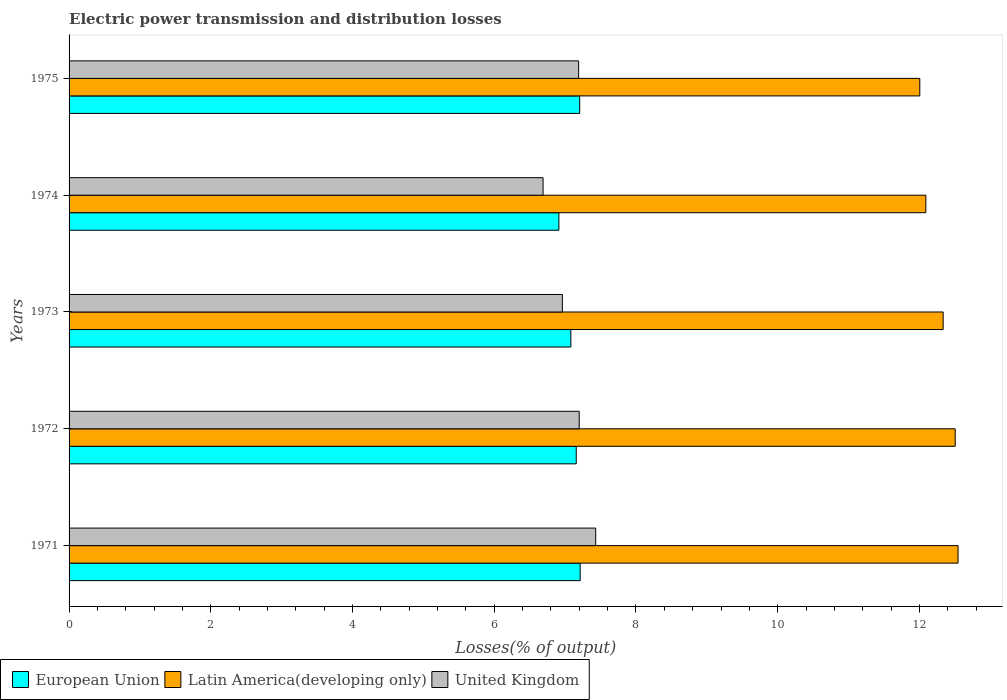Are the number of bars per tick equal to the number of legend labels?
Offer a terse response. Yes. Are the number of bars on each tick of the Y-axis equal?
Offer a terse response. Yes. How many bars are there on the 3rd tick from the top?
Offer a very short reply. 3. How many bars are there on the 4th tick from the bottom?
Provide a short and direct response. 3. What is the electric power transmission and distribution losses in United Kingdom in 1974?
Make the answer very short. 6.69. Across all years, what is the maximum electric power transmission and distribution losses in United Kingdom?
Offer a terse response. 7.43. Across all years, what is the minimum electric power transmission and distribution losses in United Kingdom?
Your response must be concise. 6.69. In which year was the electric power transmission and distribution losses in European Union maximum?
Ensure brevity in your answer.  1971. In which year was the electric power transmission and distribution losses in European Union minimum?
Your response must be concise. 1974. What is the total electric power transmission and distribution losses in Latin America(developing only) in the graph?
Your answer should be very brief. 61.48. What is the difference between the electric power transmission and distribution losses in United Kingdom in 1971 and that in 1973?
Ensure brevity in your answer.  0.47. What is the difference between the electric power transmission and distribution losses in European Union in 1975 and the electric power transmission and distribution losses in Latin America(developing only) in 1972?
Make the answer very short. -5.3. What is the average electric power transmission and distribution losses in Latin America(developing only) per year?
Ensure brevity in your answer.  12.3. In the year 1974, what is the difference between the electric power transmission and distribution losses in Latin America(developing only) and electric power transmission and distribution losses in European Union?
Ensure brevity in your answer.  5.18. What is the ratio of the electric power transmission and distribution losses in United Kingdom in 1974 to that in 1975?
Ensure brevity in your answer.  0.93. Is the difference between the electric power transmission and distribution losses in Latin America(developing only) in 1971 and 1975 greater than the difference between the electric power transmission and distribution losses in European Union in 1971 and 1975?
Provide a succinct answer. Yes. What is the difference between the highest and the second highest electric power transmission and distribution losses in United Kingdom?
Your response must be concise. 0.23. What is the difference between the highest and the lowest electric power transmission and distribution losses in European Union?
Offer a very short reply. 0.3. Is the sum of the electric power transmission and distribution losses in Latin America(developing only) in 1971 and 1975 greater than the maximum electric power transmission and distribution losses in European Union across all years?
Your response must be concise. Yes. What does the 2nd bar from the top in 1975 represents?
Make the answer very short. Latin America(developing only). What does the 2nd bar from the bottom in 1974 represents?
Ensure brevity in your answer.  Latin America(developing only). How many bars are there?
Make the answer very short. 15. Are all the bars in the graph horizontal?
Keep it short and to the point. Yes. How many years are there in the graph?
Your response must be concise. 5. What is the difference between two consecutive major ticks on the X-axis?
Your answer should be compact. 2. Does the graph contain any zero values?
Offer a very short reply. No. How are the legend labels stacked?
Your answer should be very brief. Horizontal. What is the title of the graph?
Provide a short and direct response. Electric power transmission and distribution losses. Does "Tunisia" appear as one of the legend labels in the graph?
Offer a very short reply. No. What is the label or title of the X-axis?
Offer a terse response. Losses(% of output). What is the Losses(% of output) of European Union in 1971?
Provide a succinct answer. 7.21. What is the Losses(% of output) of Latin America(developing only) in 1971?
Make the answer very short. 12.55. What is the Losses(% of output) of United Kingdom in 1971?
Your answer should be compact. 7.43. What is the Losses(% of output) in European Union in 1972?
Provide a short and direct response. 7.16. What is the Losses(% of output) of Latin America(developing only) in 1972?
Make the answer very short. 12.51. What is the Losses(% of output) in United Kingdom in 1972?
Your response must be concise. 7.2. What is the Losses(% of output) in European Union in 1973?
Your answer should be compact. 7.08. What is the Losses(% of output) of Latin America(developing only) in 1973?
Provide a short and direct response. 12.33. What is the Losses(% of output) in United Kingdom in 1973?
Your answer should be very brief. 6.96. What is the Losses(% of output) in European Union in 1974?
Your response must be concise. 6.91. What is the Losses(% of output) in Latin America(developing only) in 1974?
Offer a terse response. 12.09. What is the Losses(% of output) in United Kingdom in 1974?
Provide a succinct answer. 6.69. What is the Losses(% of output) in European Union in 1975?
Offer a terse response. 7.21. What is the Losses(% of output) of Latin America(developing only) in 1975?
Keep it short and to the point. 12.01. What is the Losses(% of output) in United Kingdom in 1975?
Your response must be concise. 7.19. Across all years, what is the maximum Losses(% of output) of European Union?
Provide a short and direct response. 7.21. Across all years, what is the maximum Losses(% of output) in Latin America(developing only)?
Make the answer very short. 12.55. Across all years, what is the maximum Losses(% of output) of United Kingdom?
Provide a short and direct response. 7.43. Across all years, what is the minimum Losses(% of output) of European Union?
Keep it short and to the point. 6.91. Across all years, what is the minimum Losses(% of output) in Latin America(developing only)?
Give a very brief answer. 12.01. Across all years, what is the minimum Losses(% of output) of United Kingdom?
Your answer should be compact. 6.69. What is the total Losses(% of output) of European Union in the graph?
Your response must be concise. 35.57. What is the total Losses(% of output) in Latin America(developing only) in the graph?
Your response must be concise. 61.48. What is the total Losses(% of output) of United Kingdom in the graph?
Your answer should be very brief. 35.47. What is the difference between the Losses(% of output) in European Union in 1971 and that in 1972?
Your response must be concise. 0.06. What is the difference between the Losses(% of output) in Latin America(developing only) in 1971 and that in 1972?
Your answer should be compact. 0.04. What is the difference between the Losses(% of output) of United Kingdom in 1971 and that in 1972?
Offer a very short reply. 0.23. What is the difference between the Losses(% of output) in European Union in 1971 and that in 1973?
Your answer should be compact. 0.13. What is the difference between the Losses(% of output) in Latin America(developing only) in 1971 and that in 1973?
Your answer should be very brief. 0.21. What is the difference between the Losses(% of output) of United Kingdom in 1971 and that in 1973?
Ensure brevity in your answer.  0.47. What is the difference between the Losses(% of output) of European Union in 1971 and that in 1974?
Make the answer very short. 0.3. What is the difference between the Losses(% of output) in Latin America(developing only) in 1971 and that in 1974?
Offer a very short reply. 0.45. What is the difference between the Losses(% of output) in United Kingdom in 1971 and that in 1974?
Your answer should be very brief. 0.74. What is the difference between the Losses(% of output) in European Union in 1971 and that in 1975?
Offer a terse response. 0.01. What is the difference between the Losses(% of output) in Latin America(developing only) in 1971 and that in 1975?
Provide a short and direct response. 0.54. What is the difference between the Losses(% of output) in United Kingdom in 1971 and that in 1975?
Your answer should be compact. 0.24. What is the difference between the Losses(% of output) of European Union in 1972 and that in 1973?
Give a very brief answer. 0.08. What is the difference between the Losses(% of output) in Latin America(developing only) in 1972 and that in 1973?
Your answer should be very brief. 0.17. What is the difference between the Losses(% of output) in United Kingdom in 1972 and that in 1973?
Give a very brief answer. 0.24. What is the difference between the Losses(% of output) of European Union in 1972 and that in 1974?
Ensure brevity in your answer.  0.24. What is the difference between the Losses(% of output) in Latin America(developing only) in 1972 and that in 1974?
Give a very brief answer. 0.41. What is the difference between the Losses(% of output) of United Kingdom in 1972 and that in 1974?
Ensure brevity in your answer.  0.51. What is the difference between the Losses(% of output) of European Union in 1972 and that in 1975?
Provide a succinct answer. -0.05. What is the difference between the Losses(% of output) in Latin America(developing only) in 1972 and that in 1975?
Offer a very short reply. 0.5. What is the difference between the Losses(% of output) in United Kingdom in 1972 and that in 1975?
Your response must be concise. 0.01. What is the difference between the Losses(% of output) of European Union in 1973 and that in 1974?
Make the answer very short. 0.17. What is the difference between the Losses(% of output) of Latin America(developing only) in 1973 and that in 1974?
Make the answer very short. 0.24. What is the difference between the Losses(% of output) of United Kingdom in 1973 and that in 1974?
Offer a terse response. 0.27. What is the difference between the Losses(% of output) in European Union in 1973 and that in 1975?
Offer a terse response. -0.12. What is the difference between the Losses(% of output) in Latin America(developing only) in 1973 and that in 1975?
Your answer should be compact. 0.33. What is the difference between the Losses(% of output) of United Kingdom in 1973 and that in 1975?
Offer a terse response. -0.23. What is the difference between the Losses(% of output) in European Union in 1974 and that in 1975?
Your answer should be very brief. -0.29. What is the difference between the Losses(% of output) of Latin America(developing only) in 1974 and that in 1975?
Your answer should be very brief. 0.09. What is the difference between the Losses(% of output) of United Kingdom in 1974 and that in 1975?
Make the answer very short. -0.5. What is the difference between the Losses(% of output) of European Union in 1971 and the Losses(% of output) of Latin America(developing only) in 1972?
Your answer should be compact. -5.29. What is the difference between the Losses(% of output) of European Union in 1971 and the Losses(% of output) of United Kingdom in 1972?
Provide a short and direct response. 0.01. What is the difference between the Losses(% of output) in Latin America(developing only) in 1971 and the Losses(% of output) in United Kingdom in 1972?
Your answer should be compact. 5.35. What is the difference between the Losses(% of output) in European Union in 1971 and the Losses(% of output) in Latin America(developing only) in 1973?
Provide a succinct answer. -5.12. What is the difference between the Losses(% of output) of European Union in 1971 and the Losses(% of output) of United Kingdom in 1973?
Ensure brevity in your answer.  0.25. What is the difference between the Losses(% of output) in Latin America(developing only) in 1971 and the Losses(% of output) in United Kingdom in 1973?
Provide a succinct answer. 5.58. What is the difference between the Losses(% of output) of European Union in 1971 and the Losses(% of output) of Latin America(developing only) in 1974?
Your answer should be very brief. -4.88. What is the difference between the Losses(% of output) in European Union in 1971 and the Losses(% of output) in United Kingdom in 1974?
Your response must be concise. 0.52. What is the difference between the Losses(% of output) of Latin America(developing only) in 1971 and the Losses(% of output) of United Kingdom in 1974?
Offer a terse response. 5.86. What is the difference between the Losses(% of output) of European Union in 1971 and the Losses(% of output) of Latin America(developing only) in 1975?
Your answer should be compact. -4.79. What is the difference between the Losses(% of output) in European Union in 1971 and the Losses(% of output) in United Kingdom in 1975?
Offer a terse response. 0.02. What is the difference between the Losses(% of output) of Latin America(developing only) in 1971 and the Losses(% of output) of United Kingdom in 1975?
Provide a short and direct response. 5.35. What is the difference between the Losses(% of output) in European Union in 1972 and the Losses(% of output) in Latin America(developing only) in 1973?
Your response must be concise. -5.18. What is the difference between the Losses(% of output) of European Union in 1972 and the Losses(% of output) of United Kingdom in 1973?
Provide a short and direct response. 0.2. What is the difference between the Losses(% of output) in Latin America(developing only) in 1972 and the Losses(% of output) in United Kingdom in 1973?
Your answer should be compact. 5.54. What is the difference between the Losses(% of output) of European Union in 1972 and the Losses(% of output) of Latin America(developing only) in 1974?
Provide a succinct answer. -4.93. What is the difference between the Losses(% of output) of European Union in 1972 and the Losses(% of output) of United Kingdom in 1974?
Provide a succinct answer. 0.47. What is the difference between the Losses(% of output) of Latin America(developing only) in 1972 and the Losses(% of output) of United Kingdom in 1974?
Make the answer very short. 5.82. What is the difference between the Losses(% of output) of European Union in 1972 and the Losses(% of output) of Latin America(developing only) in 1975?
Provide a short and direct response. -4.85. What is the difference between the Losses(% of output) of European Union in 1972 and the Losses(% of output) of United Kingdom in 1975?
Make the answer very short. -0.03. What is the difference between the Losses(% of output) in Latin America(developing only) in 1972 and the Losses(% of output) in United Kingdom in 1975?
Offer a terse response. 5.31. What is the difference between the Losses(% of output) of European Union in 1973 and the Losses(% of output) of Latin America(developing only) in 1974?
Ensure brevity in your answer.  -5.01. What is the difference between the Losses(% of output) of European Union in 1973 and the Losses(% of output) of United Kingdom in 1974?
Ensure brevity in your answer.  0.39. What is the difference between the Losses(% of output) of Latin America(developing only) in 1973 and the Losses(% of output) of United Kingdom in 1974?
Your answer should be compact. 5.65. What is the difference between the Losses(% of output) of European Union in 1973 and the Losses(% of output) of Latin America(developing only) in 1975?
Provide a short and direct response. -4.92. What is the difference between the Losses(% of output) of European Union in 1973 and the Losses(% of output) of United Kingdom in 1975?
Ensure brevity in your answer.  -0.11. What is the difference between the Losses(% of output) of Latin America(developing only) in 1973 and the Losses(% of output) of United Kingdom in 1975?
Offer a terse response. 5.14. What is the difference between the Losses(% of output) of European Union in 1974 and the Losses(% of output) of Latin America(developing only) in 1975?
Make the answer very short. -5.09. What is the difference between the Losses(% of output) of European Union in 1974 and the Losses(% of output) of United Kingdom in 1975?
Your answer should be very brief. -0.28. What is the difference between the Losses(% of output) in Latin America(developing only) in 1974 and the Losses(% of output) in United Kingdom in 1975?
Your answer should be compact. 4.9. What is the average Losses(% of output) in European Union per year?
Keep it short and to the point. 7.11. What is the average Losses(% of output) in Latin America(developing only) per year?
Your answer should be very brief. 12.3. What is the average Losses(% of output) in United Kingdom per year?
Your answer should be compact. 7.09. In the year 1971, what is the difference between the Losses(% of output) in European Union and Losses(% of output) in Latin America(developing only)?
Keep it short and to the point. -5.33. In the year 1971, what is the difference between the Losses(% of output) in European Union and Losses(% of output) in United Kingdom?
Offer a terse response. -0.22. In the year 1971, what is the difference between the Losses(% of output) of Latin America(developing only) and Losses(% of output) of United Kingdom?
Your response must be concise. 5.11. In the year 1972, what is the difference between the Losses(% of output) of European Union and Losses(% of output) of Latin America(developing only)?
Give a very brief answer. -5.35. In the year 1972, what is the difference between the Losses(% of output) of European Union and Losses(% of output) of United Kingdom?
Offer a very short reply. -0.04. In the year 1972, what is the difference between the Losses(% of output) in Latin America(developing only) and Losses(% of output) in United Kingdom?
Ensure brevity in your answer.  5.31. In the year 1973, what is the difference between the Losses(% of output) of European Union and Losses(% of output) of Latin America(developing only)?
Your answer should be compact. -5.25. In the year 1973, what is the difference between the Losses(% of output) in European Union and Losses(% of output) in United Kingdom?
Provide a succinct answer. 0.12. In the year 1973, what is the difference between the Losses(% of output) in Latin America(developing only) and Losses(% of output) in United Kingdom?
Provide a short and direct response. 5.37. In the year 1974, what is the difference between the Losses(% of output) of European Union and Losses(% of output) of Latin America(developing only)?
Your answer should be compact. -5.18. In the year 1974, what is the difference between the Losses(% of output) of European Union and Losses(% of output) of United Kingdom?
Give a very brief answer. 0.22. In the year 1974, what is the difference between the Losses(% of output) in Latin America(developing only) and Losses(% of output) in United Kingdom?
Offer a very short reply. 5.4. In the year 1975, what is the difference between the Losses(% of output) in European Union and Losses(% of output) in Latin America(developing only)?
Keep it short and to the point. -4.8. In the year 1975, what is the difference between the Losses(% of output) of European Union and Losses(% of output) of United Kingdom?
Make the answer very short. 0.02. In the year 1975, what is the difference between the Losses(% of output) of Latin America(developing only) and Losses(% of output) of United Kingdom?
Your response must be concise. 4.81. What is the ratio of the Losses(% of output) in European Union in 1971 to that in 1972?
Your response must be concise. 1.01. What is the ratio of the Losses(% of output) of Latin America(developing only) in 1971 to that in 1972?
Give a very brief answer. 1. What is the ratio of the Losses(% of output) in United Kingdom in 1971 to that in 1972?
Keep it short and to the point. 1.03. What is the ratio of the Losses(% of output) of European Union in 1971 to that in 1973?
Offer a terse response. 1.02. What is the ratio of the Losses(% of output) of Latin America(developing only) in 1971 to that in 1973?
Make the answer very short. 1.02. What is the ratio of the Losses(% of output) in United Kingdom in 1971 to that in 1973?
Your response must be concise. 1.07. What is the ratio of the Losses(% of output) of European Union in 1971 to that in 1974?
Provide a short and direct response. 1.04. What is the ratio of the Losses(% of output) in Latin America(developing only) in 1971 to that in 1974?
Provide a short and direct response. 1.04. What is the ratio of the Losses(% of output) of United Kingdom in 1971 to that in 1974?
Provide a short and direct response. 1.11. What is the ratio of the Losses(% of output) of Latin America(developing only) in 1971 to that in 1975?
Give a very brief answer. 1.04. What is the ratio of the Losses(% of output) in United Kingdom in 1971 to that in 1975?
Provide a short and direct response. 1.03. What is the ratio of the Losses(% of output) in European Union in 1972 to that in 1973?
Ensure brevity in your answer.  1.01. What is the ratio of the Losses(% of output) in Latin America(developing only) in 1972 to that in 1973?
Offer a very short reply. 1.01. What is the ratio of the Losses(% of output) in United Kingdom in 1972 to that in 1973?
Offer a very short reply. 1.03. What is the ratio of the Losses(% of output) in European Union in 1972 to that in 1974?
Offer a terse response. 1.04. What is the ratio of the Losses(% of output) of Latin America(developing only) in 1972 to that in 1974?
Your answer should be compact. 1.03. What is the ratio of the Losses(% of output) in United Kingdom in 1972 to that in 1974?
Provide a succinct answer. 1.08. What is the ratio of the Losses(% of output) in Latin America(developing only) in 1972 to that in 1975?
Your answer should be very brief. 1.04. What is the ratio of the Losses(% of output) in United Kingdom in 1972 to that in 1975?
Your response must be concise. 1. What is the ratio of the Losses(% of output) of European Union in 1973 to that in 1974?
Make the answer very short. 1.02. What is the ratio of the Losses(% of output) in Latin America(developing only) in 1973 to that in 1974?
Your answer should be very brief. 1.02. What is the ratio of the Losses(% of output) of United Kingdom in 1973 to that in 1974?
Offer a very short reply. 1.04. What is the ratio of the Losses(% of output) of European Union in 1973 to that in 1975?
Give a very brief answer. 0.98. What is the ratio of the Losses(% of output) of Latin America(developing only) in 1973 to that in 1975?
Make the answer very short. 1.03. What is the ratio of the Losses(% of output) in United Kingdom in 1973 to that in 1975?
Your answer should be compact. 0.97. What is the ratio of the Losses(% of output) of European Union in 1974 to that in 1975?
Provide a succinct answer. 0.96. What is the ratio of the Losses(% of output) in Latin America(developing only) in 1974 to that in 1975?
Your answer should be very brief. 1.01. What is the ratio of the Losses(% of output) of United Kingdom in 1974 to that in 1975?
Your response must be concise. 0.93. What is the difference between the highest and the second highest Losses(% of output) in European Union?
Your answer should be very brief. 0.01. What is the difference between the highest and the second highest Losses(% of output) in Latin America(developing only)?
Offer a terse response. 0.04. What is the difference between the highest and the second highest Losses(% of output) in United Kingdom?
Ensure brevity in your answer.  0.23. What is the difference between the highest and the lowest Losses(% of output) of European Union?
Provide a succinct answer. 0.3. What is the difference between the highest and the lowest Losses(% of output) of Latin America(developing only)?
Make the answer very short. 0.54. What is the difference between the highest and the lowest Losses(% of output) in United Kingdom?
Provide a short and direct response. 0.74. 